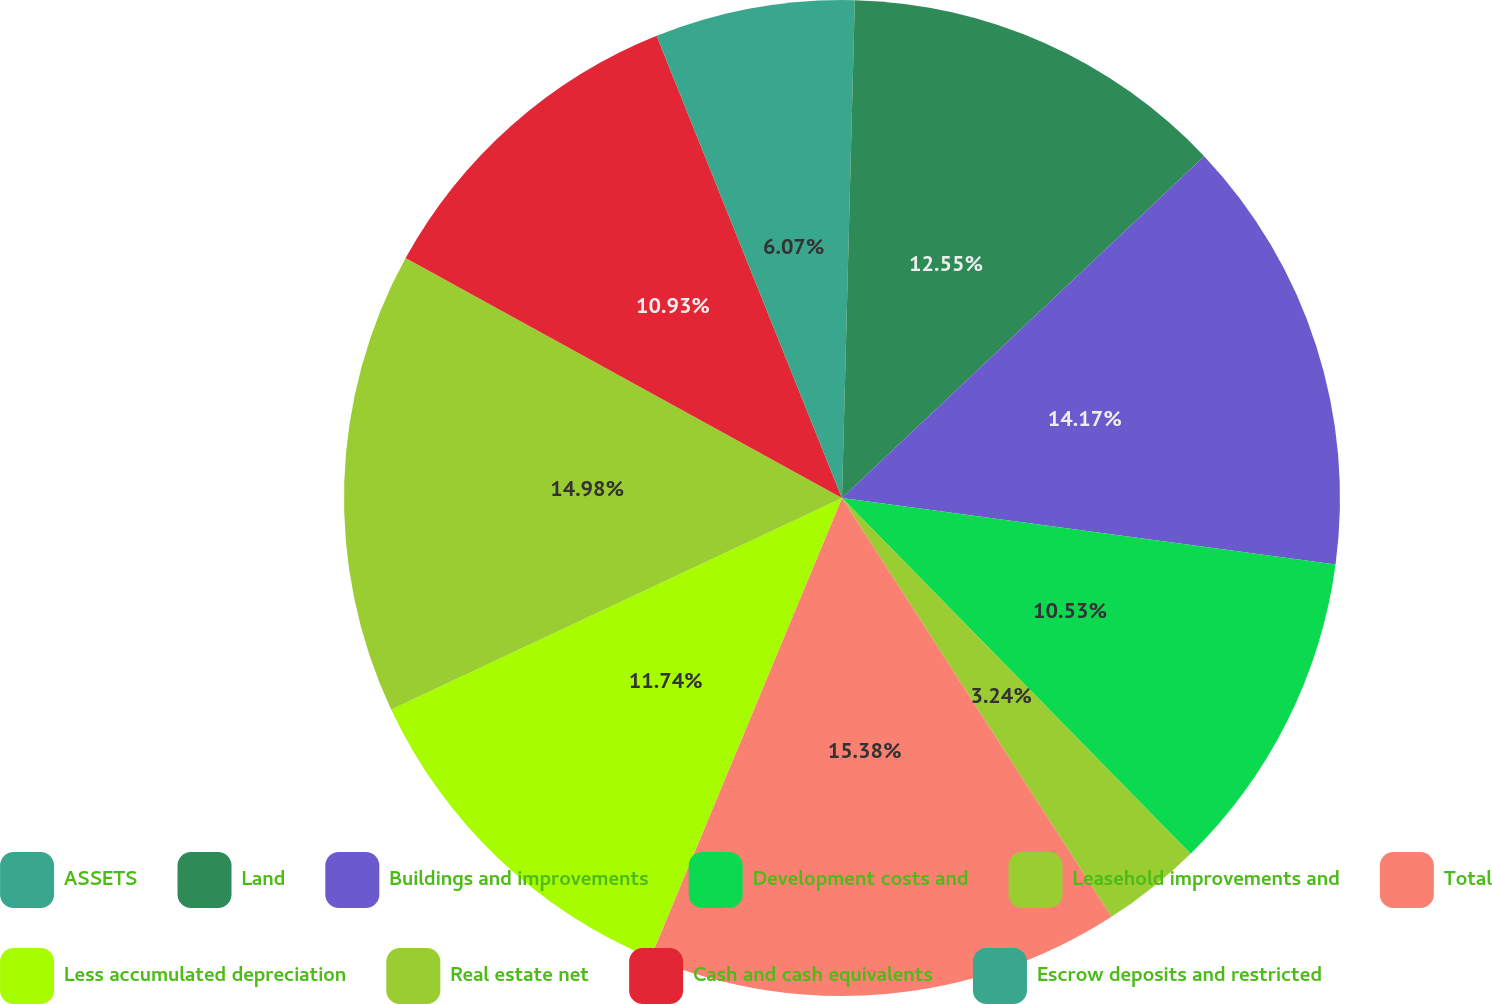Convert chart to OTSL. <chart><loc_0><loc_0><loc_500><loc_500><pie_chart><fcel>ASSETS<fcel>Land<fcel>Buildings and improvements<fcel>Development costs and<fcel>Leasehold improvements and<fcel>Total<fcel>Less accumulated depreciation<fcel>Real estate net<fcel>Cash and cash equivalents<fcel>Escrow deposits and restricted<nl><fcel>0.41%<fcel>12.55%<fcel>14.17%<fcel>10.53%<fcel>3.24%<fcel>15.38%<fcel>11.74%<fcel>14.98%<fcel>10.93%<fcel>6.07%<nl></chart> 